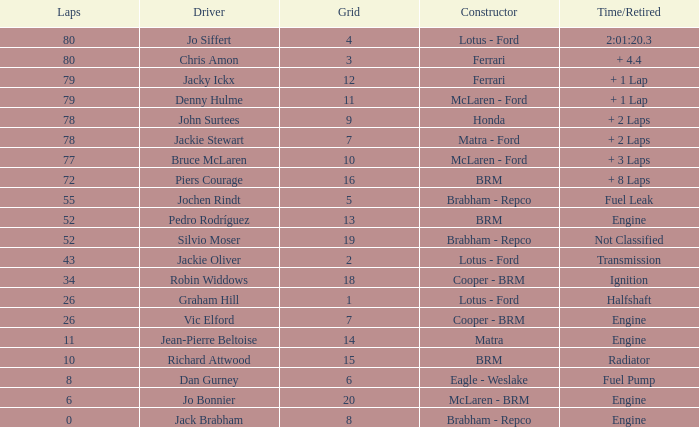What driver has a grid greater than 19? Jo Bonnier. 